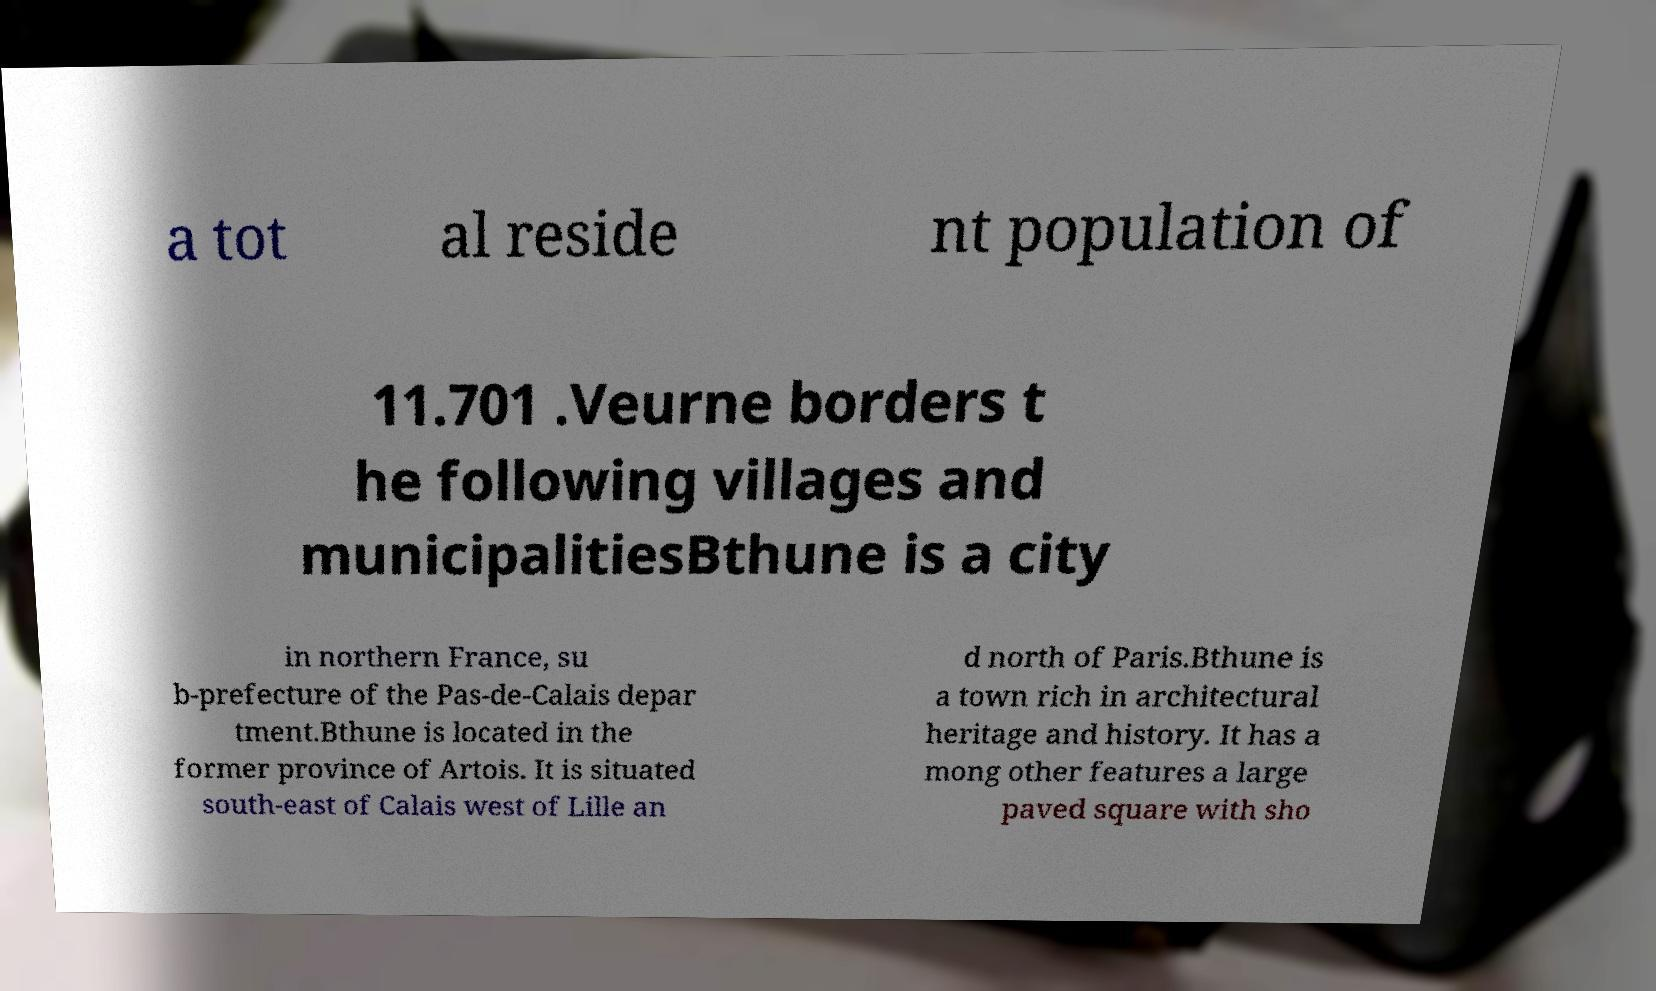For documentation purposes, I need the text within this image transcribed. Could you provide that? a tot al reside nt population of 11.701 .Veurne borders t he following villages and municipalitiesBthune is a city in northern France, su b-prefecture of the Pas-de-Calais depar tment.Bthune is located in the former province of Artois. It is situated south-east of Calais west of Lille an d north of Paris.Bthune is a town rich in architectural heritage and history. It has a mong other features a large paved square with sho 